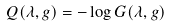Convert formula to latex. <formula><loc_0><loc_0><loc_500><loc_500>Q ( \lambda , g ) = - \log G ( \lambda , g )</formula> 